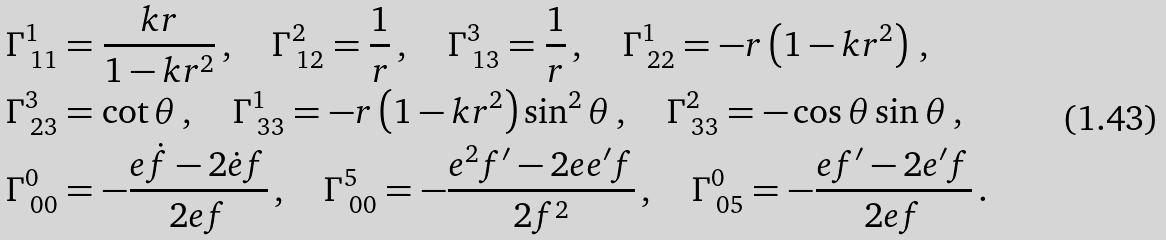<formula> <loc_0><loc_0><loc_500><loc_500>& \Gamma ^ { 1 } _ { \ 1 1 } = \frac { k r } { 1 - k r ^ { 2 } } \, , \quad \Gamma ^ { 2 } _ { \ 1 2 } = \frac { 1 } { r } \, , \quad \Gamma ^ { 3 } _ { \ 1 3 } = \frac { 1 } { r } \, , \quad \Gamma ^ { 1 } _ { \ 2 2 } = - r \left ( 1 - k r ^ { 2 } \right ) \, , \\ & \Gamma ^ { 3 } _ { \ 2 3 } = \cot \theta \, , \quad \Gamma ^ { 1 } _ { \ 3 3 } = - r \left ( 1 - k r ^ { 2 } \right ) \sin ^ { 2 } \theta \, , \quad \Gamma ^ { 2 } _ { \ 3 3 } = - \cos \theta \sin \theta \, , \\ & \Gamma ^ { 0 } _ { \ 0 0 } = - \frac { e \dot { f } - 2 \dot { e } f } { 2 e f } \, , \quad \Gamma ^ { 5 } _ { \ 0 0 } = - \frac { e ^ { 2 } f ^ { \prime } - 2 e e ^ { \prime } f } { 2 f ^ { 2 } } \, , \quad \Gamma ^ { 0 } _ { \ 0 5 } = - \frac { e f ^ { \prime } - 2 e ^ { \prime } f } { 2 e f } \, .</formula> 